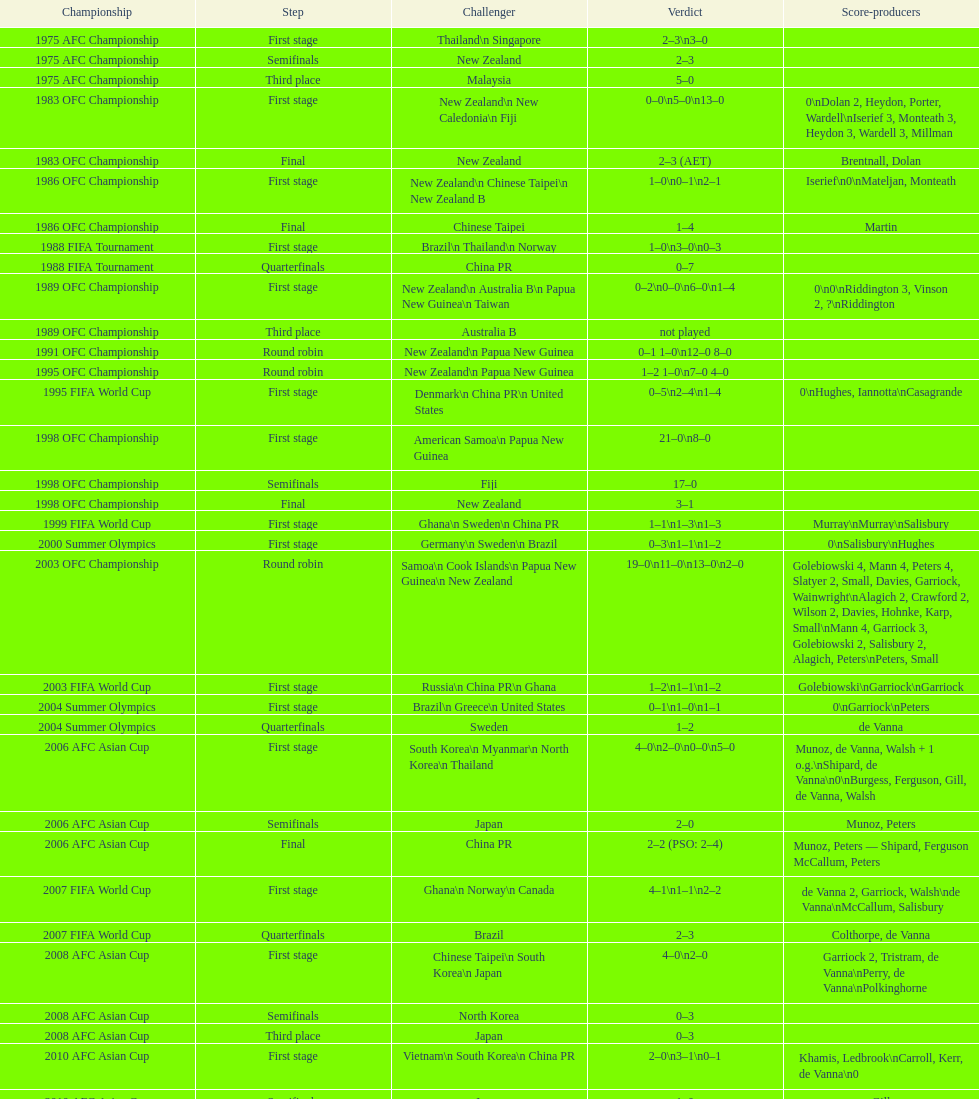What was the total goals made in the 1983 ofc championship? 18. Can you give me this table as a dict? {'header': ['Championship', 'Step', 'Challenger', 'Verdict', 'Score-producers'], 'rows': [['1975 AFC Championship', 'First stage', 'Thailand\\n\xa0Singapore', '2–3\\n3–0', ''], ['1975 AFC Championship', 'Semifinals', 'New Zealand', '2–3', ''], ['1975 AFC Championship', 'Third place', 'Malaysia', '5–0', ''], ['1983 OFC Championship', 'First stage', 'New Zealand\\n\xa0New Caledonia\\n\xa0Fiji', '0–0\\n5–0\\n13–0', '0\\nDolan 2, Heydon, Porter, Wardell\\nIserief 3, Monteath 3, Heydon 3, Wardell 3, Millman'], ['1983 OFC Championship', 'Final', 'New Zealand', '2–3 (AET)', 'Brentnall, Dolan'], ['1986 OFC Championship', 'First stage', 'New Zealand\\n\xa0Chinese Taipei\\n New Zealand B', '1–0\\n0–1\\n2–1', 'Iserief\\n0\\nMateljan, Monteath'], ['1986 OFC Championship', 'Final', 'Chinese Taipei', '1–4', 'Martin'], ['1988 FIFA Tournament', 'First stage', 'Brazil\\n\xa0Thailand\\n\xa0Norway', '1–0\\n3–0\\n0–3', ''], ['1988 FIFA Tournament', 'Quarterfinals', 'China PR', '0–7', ''], ['1989 OFC Championship', 'First stage', 'New Zealand\\n Australia B\\n\xa0Papua New Guinea\\n\xa0Taiwan', '0–2\\n0–0\\n6–0\\n1–4', '0\\n0\\nRiddington 3, Vinson 2,\xa0?\\nRiddington'], ['1989 OFC Championship', 'Third place', 'Australia B', 'not played', ''], ['1991 OFC Championship', 'Round robin', 'New Zealand\\n\xa0Papua New Guinea', '0–1 1–0\\n12–0 8–0', ''], ['1995 OFC Championship', 'Round robin', 'New Zealand\\n\xa0Papua New Guinea', '1–2 1–0\\n7–0 4–0', ''], ['1995 FIFA World Cup', 'First stage', 'Denmark\\n\xa0China PR\\n\xa0United States', '0–5\\n2–4\\n1–4', '0\\nHughes, Iannotta\\nCasagrande'], ['1998 OFC Championship', 'First stage', 'American Samoa\\n\xa0Papua New Guinea', '21–0\\n8–0', ''], ['1998 OFC Championship', 'Semifinals', 'Fiji', '17–0', ''], ['1998 OFC Championship', 'Final', 'New Zealand', '3–1', ''], ['1999 FIFA World Cup', 'First stage', 'Ghana\\n\xa0Sweden\\n\xa0China PR', '1–1\\n1–3\\n1–3', 'Murray\\nMurray\\nSalisbury'], ['2000 Summer Olympics', 'First stage', 'Germany\\n\xa0Sweden\\n\xa0Brazil', '0–3\\n1–1\\n1–2', '0\\nSalisbury\\nHughes'], ['2003 OFC Championship', 'Round robin', 'Samoa\\n\xa0Cook Islands\\n\xa0Papua New Guinea\\n\xa0New Zealand', '19–0\\n11–0\\n13–0\\n2–0', 'Golebiowski 4, Mann 4, Peters 4, Slatyer 2, Small, Davies, Garriock, Wainwright\\nAlagich 2, Crawford 2, Wilson 2, Davies, Hohnke, Karp, Small\\nMann 4, Garriock 3, Golebiowski 2, Salisbury 2, Alagich, Peters\\nPeters, Small'], ['2003 FIFA World Cup', 'First stage', 'Russia\\n\xa0China PR\\n\xa0Ghana', '1–2\\n1–1\\n1–2', 'Golebiowski\\nGarriock\\nGarriock'], ['2004 Summer Olympics', 'First stage', 'Brazil\\n\xa0Greece\\n\xa0United States', '0–1\\n1–0\\n1–1', '0\\nGarriock\\nPeters'], ['2004 Summer Olympics', 'Quarterfinals', 'Sweden', '1–2', 'de Vanna'], ['2006 AFC Asian Cup', 'First stage', 'South Korea\\n\xa0Myanmar\\n\xa0North Korea\\n\xa0Thailand', '4–0\\n2–0\\n0–0\\n5–0', 'Munoz, de Vanna, Walsh + 1 o.g.\\nShipard, de Vanna\\n0\\nBurgess, Ferguson, Gill, de Vanna, Walsh'], ['2006 AFC Asian Cup', 'Semifinals', 'Japan', '2–0', 'Munoz, Peters'], ['2006 AFC Asian Cup', 'Final', 'China PR', '2–2 (PSO: 2–4)', 'Munoz, Peters — Shipard, Ferguson McCallum, Peters'], ['2007 FIFA World Cup', 'First stage', 'Ghana\\n\xa0Norway\\n\xa0Canada', '4–1\\n1–1\\n2–2', 'de Vanna 2, Garriock, Walsh\\nde Vanna\\nMcCallum, Salisbury'], ['2007 FIFA World Cup', 'Quarterfinals', 'Brazil', '2–3', 'Colthorpe, de Vanna'], ['2008 AFC Asian Cup', 'First stage', 'Chinese Taipei\\n\xa0South Korea\\n\xa0Japan', '4–0\\n2–0', 'Garriock 2, Tristram, de Vanna\\nPerry, de Vanna\\nPolkinghorne'], ['2008 AFC Asian Cup', 'Semifinals', 'North Korea', '0–3', ''], ['2008 AFC Asian Cup', 'Third place', 'Japan', '0–3', ''], ['2010 AFC Asian Cup', 'First stage', 'Vietnam\\n\xa0South Korea\\n\xa0China PR', '2–0\\n3–1\\n0–1', 'Khamis, Ledbrook\\nCarroll, Kerr, de Vanna\\n0'], ['2010 AFC Asian Cup', 'Semifinals', 'Japan', '1–0', 'Gill'], ['2010 AFC Asian Cup', 'Final', 'North Korea', '1–1 (PSO: 5–4)', 'Kerr — PSO: Shipard, Ledbrook, Gill, Garriock, Simon'], ['2011 FIFA World Cup', 'First stage', 'Brazil\\n\xa0Equatorial Guinea\\n\xa0Norway', '0–1\\n3–2\\n2–1', '0\\nvan Egmond, Khamis, de Vanna\\nSimon 2'], ['2011 FIFA World Cup', 'Quarterfinals', 'Sweden', '1–3', 'Perry'], ['2012 Summer Olympics\\nAFC qualification', 'Final round', 'North Korea\\n\xa0Thailand\\n\xa0Japan\\n\xa0China PR\\n\xa0South Korea', '0–1\\n5–1\\n0–1\\n1–0\\n2–1', '0\\nHeyman 2, Butt, van Egmond, Simon\\n0\\nvan Egmond\\nButt, de Vanna'], ['2014 AFC Asian Cup', 'First stage', 'Japan\\n\xa0Jordan\\n\xa0Vietnam', 'TBD\\nTBD\\nTBD', '']]} 